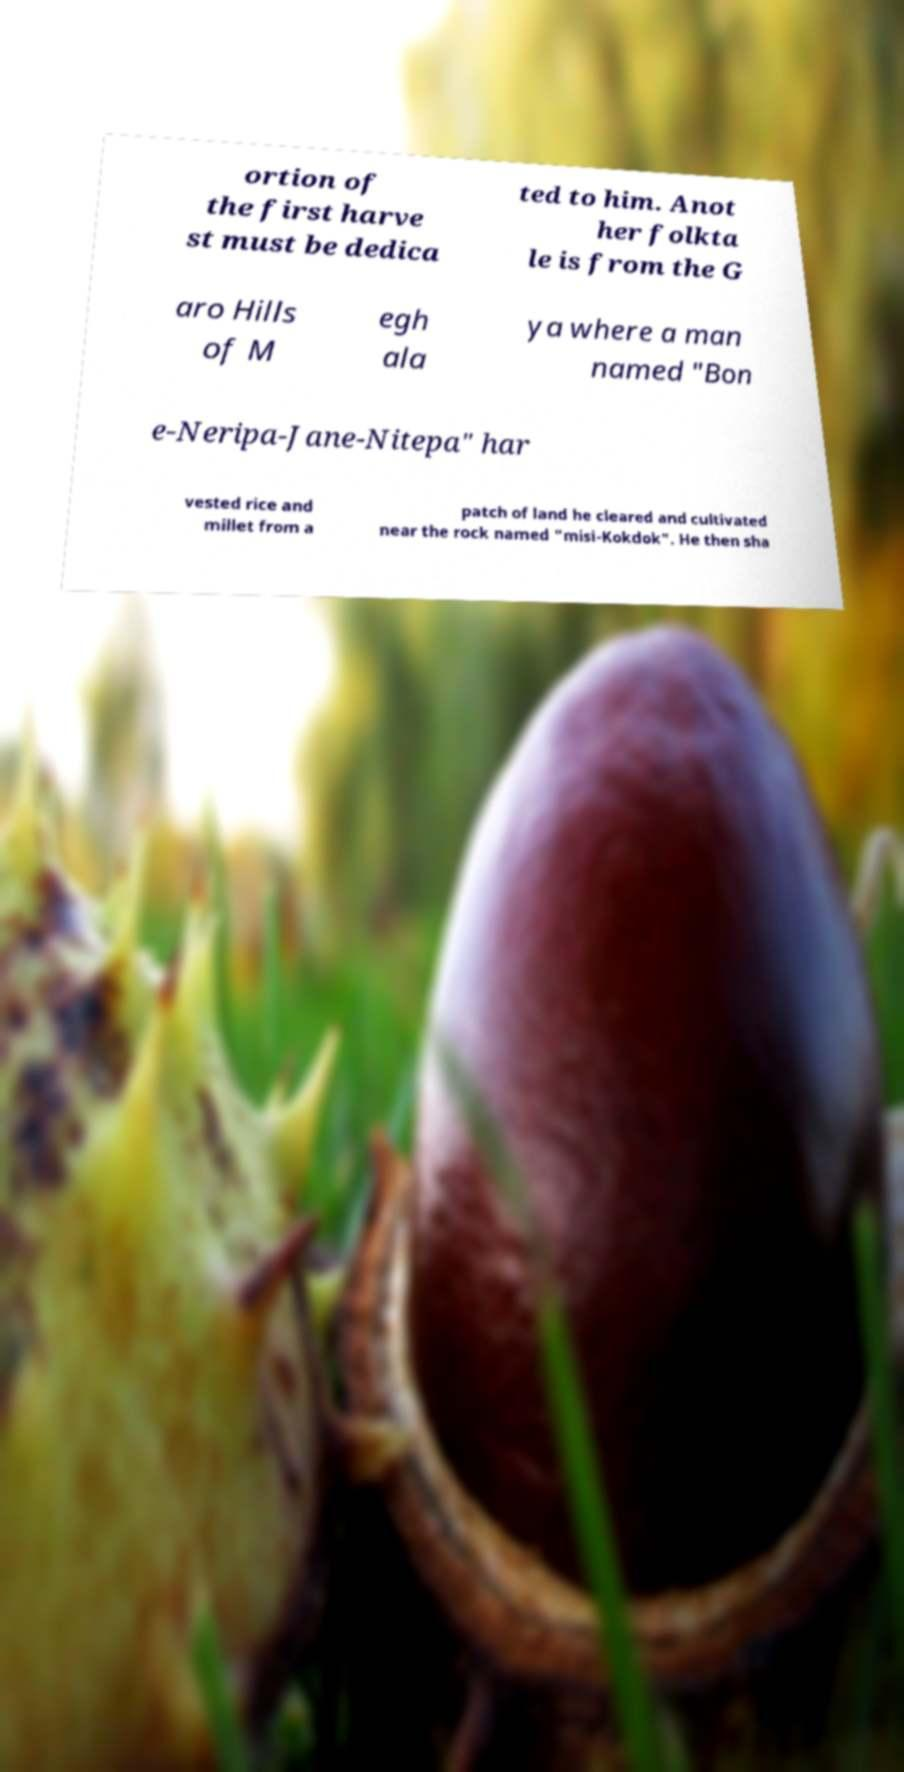There's text embedded in this image that I need extracted. Can you transcribe it verbatim? ortion of the first harve st must be dedica ted to him. Anot her folkta le is from the G aro Hills of M egh ala ya where a man named "Bon e-Neripa-Jane-Nitepa" har vested rice and millet from a patch of land he cleared and cultivated near the rock named "misi-Kokdok". He then sha 